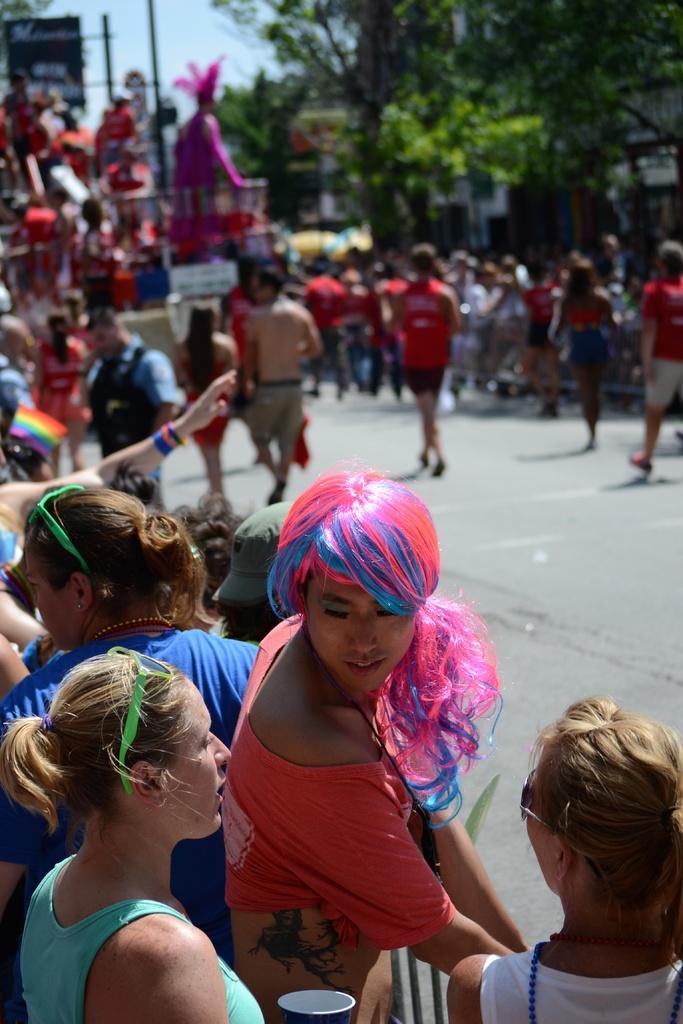Describe this image in one or two sentences. In this picture we can see a group of people and some people on the road, trees, poles and some objects and in the background we can see the sky. 